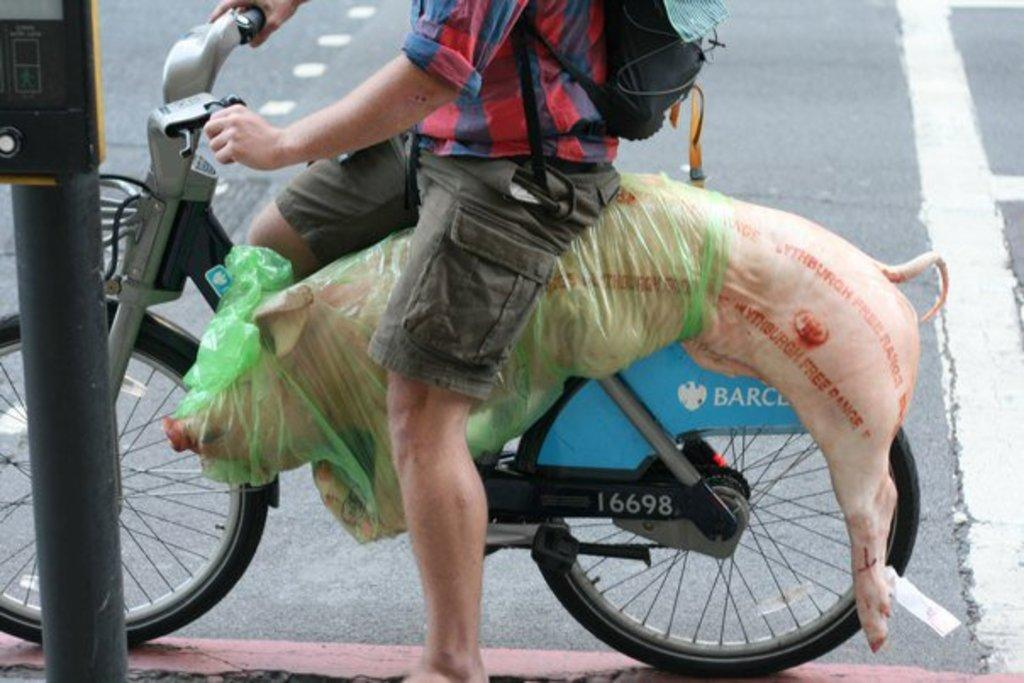What is the main subject of the image? There is a person in the image. What is the person doing in the image? The person is riding a bicycle. Is there anything unusual about what the person is carrying on the bicycle? Yes, the person is carrying a pig on the bicycle. What type of advertisement can be seen on the bushes in the image? There are no bushes or advertisements present in the image. 